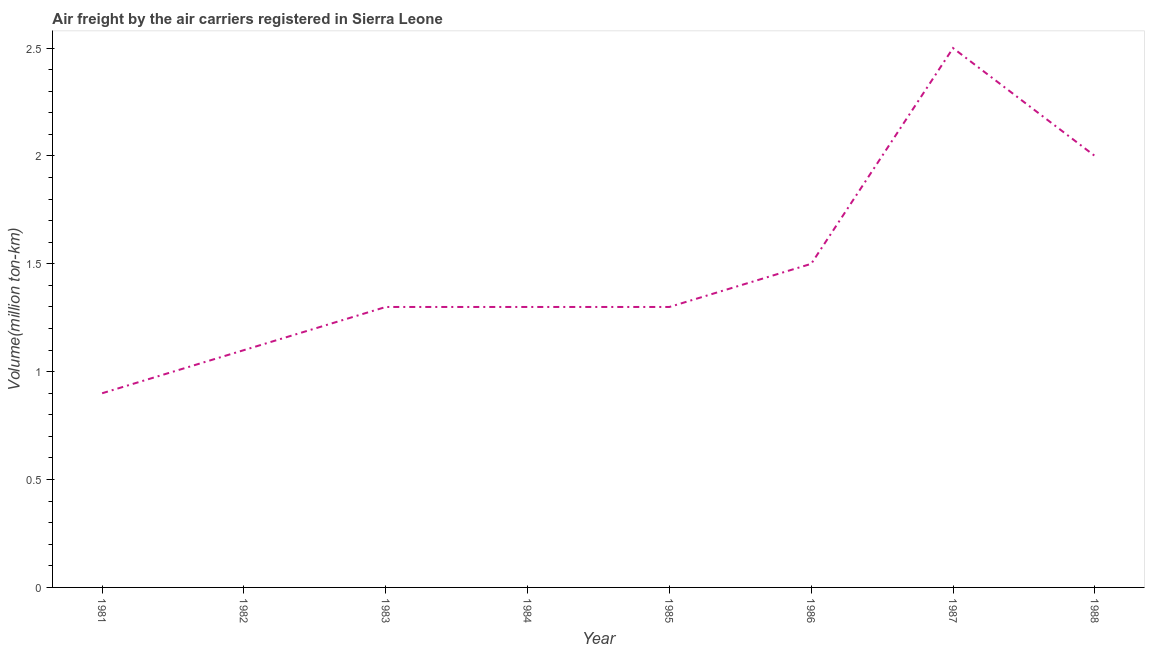Across all years, what is the minimum air freight?
Your answer should be very brief. 0.9. In which year was the air freight minimum?
Offer a terse response. 1981. What is the sum of the air freight?
Provide a short and direct response. 11.9. What is the difference between the air freight in 1984 and 1986?
Keep it short and to the point. -0.2. What is the average air freight per year?
Offer a terse response. 1.49. What is the median air freight?
Your answer should be very brief. 1.3. Do a majority of the years between 1986 and 1983 (inclusive) have air freight greater than 1.5 million ton-km?
Your answer should be very brief. Yes. What is the ratio of the air freight in 1981 to that in 1985?
Offer a terse response. 0.69. Is the difference between the air freight in 1985 and 1988 greater than the difference between any two years?
Make the answer very short. No. Is the sum of the air freight in 1984 and 1985 greater than the maximum air freight across all years?
Make the answer very short. Yes. What is the difference between the highest and the lowest air freight?
Provide a succinct answer. 1.6. Does the air freight monotonically increase over the years?
Offer a very short reply. No. How many years are there in the graph?
Your answer should be very brief. 8. What is the difference between two consecutive major ticks on the Y-axis?
Give a very brief answer. 0.5. Are the values on the major ticks of Y-axis written in scientific E-notation?
Ensure brevity in your answer.  No. Does the graph contain any zero values?
Your response must be concise. No. Does the graph contain grids?
Make the answer very short. No. What is the title of the graph?
Provide a short and direct response. Air freight by the air carriers registered in Sierra Leone. What is the label or title of the X-axis?
Provide a succinct answer. Year. What is the label or title of the Y-axis?
Give a very brief answer. Volume(million ton-km). What is the Volume(million ton-km) in 1981?
Give a very brief answer. 0.9. What is the Volume(million ton-km) in 1982?
Provide a short and direct response. 1.1. What is the Volume(million ton-km) of 1983?
Offer a terse response. 1.3. What is the Volume(million ton-km) of 1984?
Your response must be concise. 1.3. What is the Volume(million ton-km) in 1985?
Offer a terse response. 1.3. What is the Volume(million ton-km) in 1987?
Provide a succinct answer. 2.5. What is the Volume(million ton-km) of 1988?
Your answer should be compact. 2. What is the difference between the Volume(million ton-km) in 1981 and 1983?
Keep it short and to the point. -0.4. What is the difference between the Volume(million ton-km) in 1981 and 1984?
Offer a terse response. -0.4. What is the difference between the Volume(million ton-km) in 1981 and 1986?
Your response must be concise. -0.6. What is the difference between the Volume(million ton-km) in 1981 and 1987?
Provide a succinct answer. -1.6. What is the difference between the Volume(million ton-km) in 1982 and 1984?
Make the answer very short. -0.2. What is the difference between the Volume(million ton-km) in 1982 and 1985?
Give a very brief answer. -0.2. What is the difference between the Volume(million ton-km) in 1982 and 1987?
Offer a very short reply. -1.4. What is the difference between the Volume(million ton-km) in 1982 and 1988?
Make the answer very short. -0.9. What is the difference between the Volume(million ton-km) in 1983 and 1987?
Make the answer very short. -1.2. What is the difference between the Volume(million ton-km) in 1983 and 1988?
Provide a succinct answer. -0.7. What is the difference between the Volume(million ton-km) in 1984 and 1988?
Your response must be concise. -0.7. What is the difference between the Volume(million ton-km) in 1985 and 1988?
Ensure brevity in your answer.  -0.7. What is the difference between the Volume(million ton-km) in 1986 and 1988?
Provide a succinct answer. -0.5. What is the ratio of the Volume(million ton-km) in 1981 to that in 1982?
Offer a very short reply. 0.82. What is the ratio of the Volume(million ton-km) in 1981 to that in 1983?
Keep it short and to the point. 0.69. What is the ratio of the Volume(million ton-km) in 1981 to that in 1984?
Your answer should be very brief. 0.69. What is the ratio of the Volume(million ton-km) in 1981 to that in 1985?
Ensure brevity in your answer.  0.69. What is the ratio of the Volume(million ton-km) in 1981 to that in 1986?
Make the answer very short. 0.6. What is the ratio of the Volume(million ton-km) in 1981 to that in 1987?
Make the answer very short. 0.36. What is the ratio of the Volume(million ton-km) in 1981 to that in 1988?
Provide a short and direct response. 0.45. What is the ratio of the Volume(million ton-km) in 1982 to that in 1983?
Your answer should be compact. 0.85. What is the ratio of the Volume(million ton-km) in 1982 to that in 1984?
Keep it short and to the point. 0.85. What is the ratio of the Volume(million ton-km) in 1982 to that in 1985?
Give a very brief answer. 0.85. What is the ratio of the Volume(million ton-km) in 1982 to that in 1986?
Offer a very short reply. 0.73. What is the ratio of the Volume(million ton-km) in 1982 to that in 1987?
Give a very brief answer. 0.44. What is the ratio of the Volume(million ton-km) in 1982 to that in 1988?
Ensure brevity in your answer.  0.55. What is the ratio of the Volume(million ton-km) in 1983 to that in 1985?
Provide a short and direct response. 1. What is the ratio of the Volume(million ton-km) in 1983 to that in 1986?
Give a very brief answer. 0.87. What is the ratio of the Volume(million ton-km) in 1983 to that in 1987?
Offer a very short reply. 0.52. What is the ratio of the Volume(million ton-km) in 1983 to that in 1988?
Provide a short and direct response. 0.65. What is the ratio of the Volume(million ton-km) in 1984 to that in 1985?
Make the answer very short. 1. What is the ratio of the Volume(million ton-km) in 1984 to that in 1986?
Ensure brevity in your answer.  0.87. What is the ratio of the Volume(million ton-km) in 1984 to that in 1987?
Provide a short and direct response. 0.52. What is the ratio of the Volume(million ton-km) in 1984 to that in 1988?
Give a very brief answer. 0.65. What is the ratio of the Volume(million ton-km) in 1985 to that in 1986?
Make the answer very short. 0.87. What is the ratio of the Volume(million ton-km) in 1985 to that in 1987?
Keep it short and to the point. 0.52. What is the ratio of the Volume(million ton-km) in 1985 to that in 1988?
Provide a short and direct response. 0.65. What is the ratio of the Volume(million ton-km) in 1986 to that in 1988?
Your answer should be compact. 0.75. 